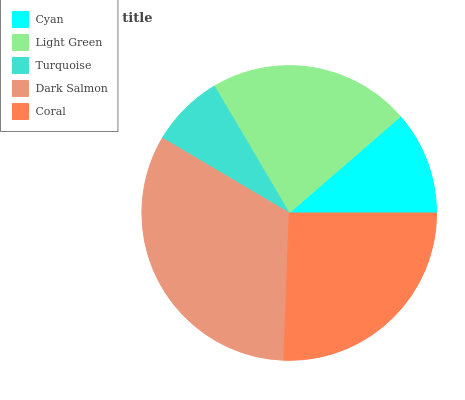Is Turquoise the minimum?
Answer yes or no. Yes. Is Dark Salmon the maximum?
Answer yes or no. Yes. Is Light Green the minimum?
Answer yes or no. No. Is Light Green the maximum?
Answer yes or no. No. Is Light Green greater than Cyan?
Answer yes or no. Yes. Is Cyan less than Light Green?
Answer yes or no. Yes. Is Cyan greater than Light Green?
Answer yes or no. No. Is Light Green less than Cyan?
Answer yes or no. No. Is Light Green the high median?
Answer yes or no. Yes. Is Light Green the low median?
Answer yes or no. Yes. Is Cyan the high median?
Answer yes or no. No. Is Dark Salmon the low median?
Answer yes or no. No. 